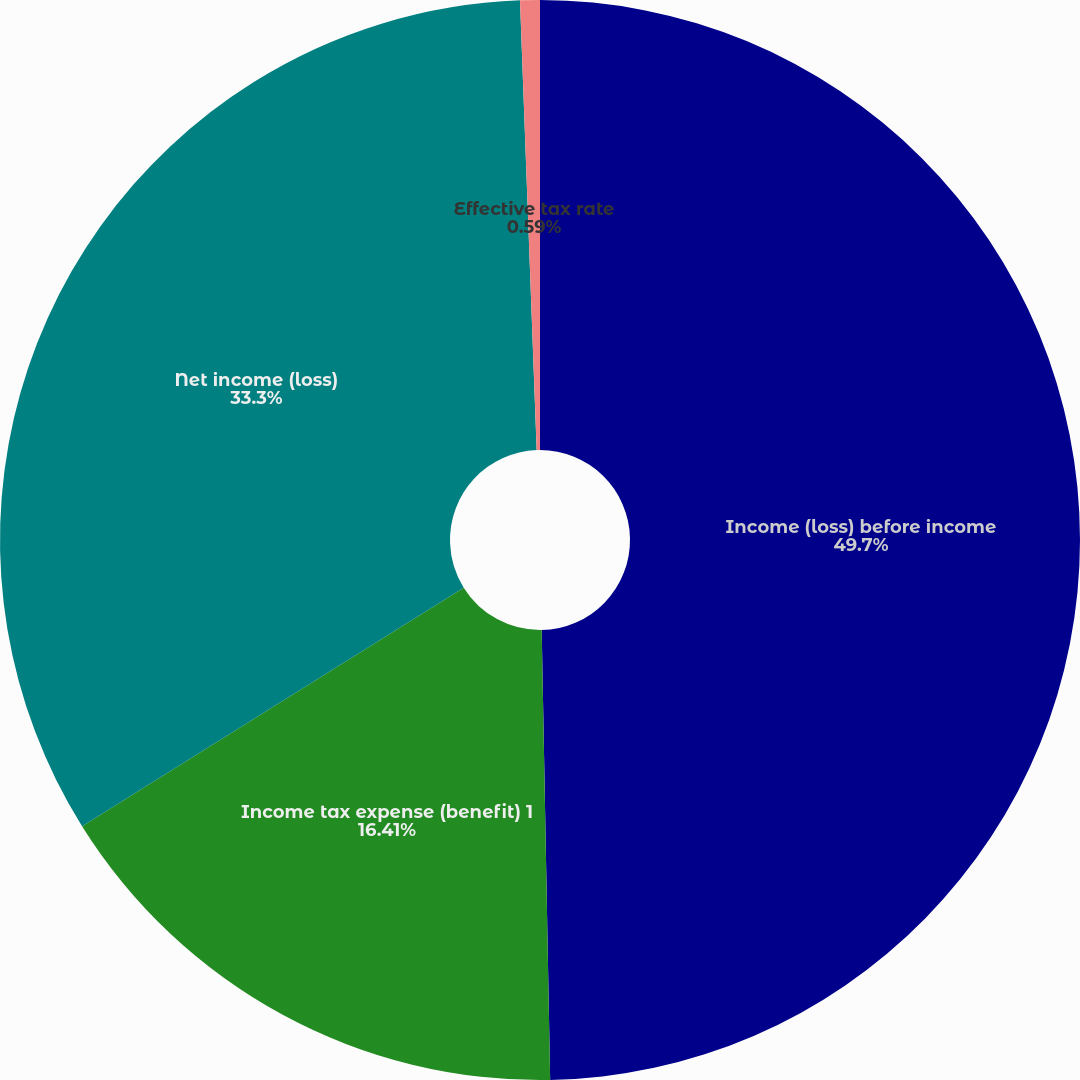<chart> <loc_0><loc_0><loc_500><loc_500><pie_chart><fcel>Income (loss) before income<fcel>Income tax expense (benefit) 1<fcel>Net income (loss)<fcel>Effective tax rate<nl><fcel>49.7%<fcel>16.41%<fcel>33.3%<fcel>0.59%<nl></chart> 